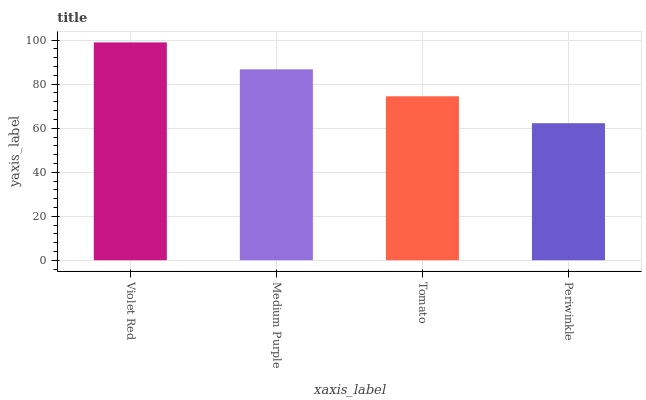Is Periwinkle the minimum?
Answer yes or no. Yes. Is Violet Red the maximum?
Answer yes or no. Yes. Is Medium Purple the minimum?
Answer yes or no. No. Is Medium Purple the maximum?
Answer yes or no. No. Is Violet Red greater than Medium Purple?
Answer yes or no. Yes. Is Medium Purple less than Violet Red?
Answer yes or no. Yes. Is Medium Purple greater than Violet Red?
Answer yes or no. No. Is Violet Red less than Medium Purple?
Answer yes or no. No. Is Medium Purple the high median?
Answer yes or no. Yes. Is Tomato the low median?
Answer yes or no. Yes. Is Periwinkle the high median?
Answer yes or no. No. Is Periwinkle the low median?
Answer yes or no. No. 